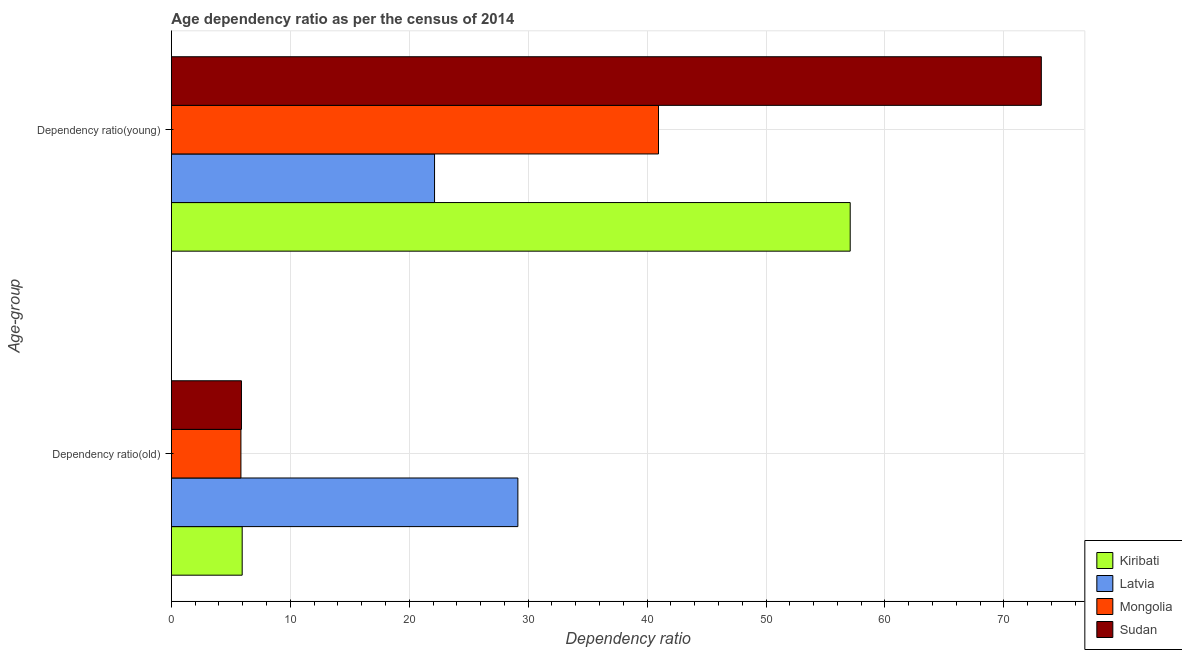How many bars are there on the 1st tick from the bottom?
Provide a short and direct response. 4. What is the label of the 1st group of bars from the top?
Provide a succinct answer. Dependency ratio(young). What is the age dependency ratio(old) in Latvia?
Offer a very short reply. 29.13. Across all countries, what is the maximum age dependency ratio(old)?
Offer a very short reply. 29.13. Across all countries, what is the minimum age dependency ratio(old)?
Offer a very short reply. 5.85. In which country was the age dependency ratio(old) maximum?
Give a very brief answer. Latvia. In which country was the age dependency ratio(young) minimum?
Provide a short and direct response. Latvia. What is the total age dependency ratio(old) in the graph?
Keep it short and to the point. 46.83. What is the difference between the age dependency ratio(young) in Mongolia and that in Kiribati?
Give a very brief answer. -16.12. What is the difference between the age dependency ratio(young) in Latvia and the age dependency ratio(old) in Sudan?
Provide a succinct answer. 16.24. What is the average age dependency ratio(old) per country?
Keep it short and to the point. 11.71. What is the difference between the age dependency ratio(young) and age dependency ratio(old) in Latvia?
Your response must be concise. -7.01. What is the ratio of the age dependency ratio(young) in Sudan to that in Mongolia?
Your answer should be compact. 1.79. What does the 1st bar from the top in Dependency ratio(old) represents?
Provide a short and direct response. Sudan. What does the 1st bar from the bottom in Dependency ratio(old) represents?
Ensure brevity in your answer.  Kiribati. How many bars are there?
Keep it short and to the point. 8. Are all the bars in the graph horizontal?
Offer a very short reply. Yes. How many countries are there in the graph?
Ensure brevity in your answer.  4. What is the difference between two consecutive major ticks on the X-axis?
Make the answer very short. 10. Are the values on the major ticks of X-axis written in scientific E-notation?
Provide a succinct answer. No. Does the graph contain any zero values?
Your answer should be very brief. No. Does the graph contain grids?
Ensure brevity in your answer.  Yes. How many legend labels are there?
Give a very brief answer. 4. How are the legend labels stacked?
Offer a very short reply. Vertical. What is the title of the graph?
Your answer should be very brief. Age dependency ratio as per the census of 2014. Does "Micronesia" appear as one of the legend labels in the graph?
Your response must be concise. No. What is the label or title of the X-axis?
Ensure brevity in your answer.  Dependency ratio. What is the label or title of the Y-axis?
Offer a terse response. Age-group. What is the Dependency ratio in Kiribati in Dependency ratio(old)?
Provide a succinct answer. 5.95. What is the Dependency ratio of Latvia in Dependency ratio(old)?
Your response must be concise. 29.13. What is the Dependency ratio of Mongolia in Dependency ratio(old)?
Offer a very short reply. 5.85. What is the Dependency ratio of Sudan in Dependency ratio(old)?
Your answer should be compact. 5.89. What is the Dependency ratio in Kiribati in Dependency ratio(young)?
Provide a short and direct response. 57.08. What is the Dependency ratio in Latvia in Dependency ratio(young)?
Provide a short and direct response. 22.13. What is the Dependency ratio in Mongolia in Dependency ratio(young)?
Offer a terse response. 40.96. What is the Dependency ratio of Sudan in Dependency ratio(young)?
Your answer should be very brief. 73.15. Across all Age-group, what is the maximum Dependency ratio of Kiribati?
Provide a succinct answer. 57.08. Across all Age-group, what is the maximum Dependency ratio in Latvia?
Your answer should be very brief. 29.13. Across all Age-group, what is the maximum Dependency ratio of Mongolia?
Offer a very short reply. 40.96. Across all Age-group, what is the maximum Dependency ratio of Sudan?
Keep it short and to the point. 73.15. Across all Age-group, what is the minimum Dependency ratio of Kiribati?
Keep it short and to the point. 5.95. Across all Age-group, what is the minimum Dependency ratio of Latvia?
Keep it short and to the point. 22.13. Across all Age-group, what is the minimum Dependency ratio in Mongolia?
Offer a terse response. 5.85. Across all Age-group, what is the minimum Dependency ratio of Sudan?
Make the answer very short. 5.89. What is the total Dependency ratio of Kiribati in the graph?
Your answer should be very brief. 63.03. What is the total Dependency ratio in Latvia in the graph?
Keep it short and to the point. 51.26. What is the total Dependency ratio of Mongolia in the graph?
Ensure brevity in your answer.  46.8. What is the total Dependency ratio of Sudan in the graph?
Offer a terse response. 79.04. What is the difference between the Dependency ratio in Kiribati in Dependency ratio(old) and that in Dependency ratio(young)?
Ensure brevity in your answer.  -51.12. What is the difference between the Dependency ratio in Latvia in Dependency ratio(old) and that in Dependency ratio(young)?
Your answer should be very brief. 7.01. What is the difference between the Dependency ratio in Mongolia in Dependency ratio(old) and that in Dependency ratio(young)?
Offer a terse response. -35.11. What is the difference between the Dependency ratio of Sudan in Dependency ratio(old) and that in Dependency ratio(young)?
Keep it short and to the point. -67.25. What is the difference between the Dependency ratio of Kiribati in Dependency ratio(old) and the Dependency ratio of Latvia in Dependency ratio(young)?
Give a very brief answer. -16.17. What is the difference between the Dependency ratio of Kiribati in Dependency ratio(old) and the Dependency ratio of Mongolia in Dependency ratio(young)?
Offer a very short reply. -35. What is the difference between the Dependency ratio of Kiribati in Dependency ratio(old) and the Dependency ratio of Sudan in Dependency ratio(young)?
Your response must be concise. -67.19. What is the difference between the Dependency ratio of Latvia in Dependency ratio(old) and the Dependency ratio of Mongolia in Dependency ratio(young)?
Provide a short and direct response. -11.82. What is the difference between the Dependency ratio of Latvia in Dependency ratio(old) and the Dependency ratio of Sudan in Dependency ratio(young)?
Provide a succinct answer. -44.01. What is the difference between the Dependency ratio of Mongolia in Dependency ratio(old) and the Dependency ratio of Sudan in Dependency ratio(young)?
Make the answer very short. -67.3. What is the average Dependency ratio in Kiribati per Age-group?
Ensure brevity in your answer.  31.51. What is the average Dependency ratio in Latvia per Age-group?
Give a very brief answer. 25.63. What is the average Dependency ratio in Mongolia per Age-group?
Offer a very short reply. 23.4. What is the average Dependency ratio of Sudan per Age-group?
Give a very brief answer. 39.52. What is the difference between the Dependency ratio in Kiribati and Dependency ratio in Latvia in Dependency ratio(old)?
Your answer should be compact. -23.18. What is the difference between the Dependency ratio of Kiribati and Dependency ratio of Mongolia in Dependency ratio(old)?
Offer a terse response. 0.11. What is the difference between the Dependency ratio in Kiribati and Dependency ratio in Sudan in Dependency ratio(old)?
Your response must be concise. 0.06. What is the difference between the Dependency ratio in Latvia and Dependency ratio in Mongolia in Dependency ratio(old)?
Your answer should be compact. 23.29. What is the difference between the Dependency ratio in Latvia and Dependency ratio in Sudan in Dependency ratio(old)?
Provide a succinct answer. 23.24. What is the difference between the Dependency ratio of Mongolia and Dependency ratio of Sudan in Dependency ratio(old)?
Ensure brevity in your answer.  -0.05. What is the difference between the Dependency ratio of Kiribati and Dependency ratio of Latvia in Dependency ratio(young)?
Give a very brief answer. 34.95. What is the difference between the Dependency ratio of Kiribati and Dependency ratio of Mongolia in Dependency ratio(young)?
Your answer should be compact. 16.12. What is the difference between the Dependency ratio in Kiribati and Dependency ratio in Sudan in Dependency ratio(young)?
Ensure brevity in your answer.  -16.07. What is the difference between the Dependency ratio of Latvia and Dependency ratio of Mongolia in Dependency ratio(young)?
Offer a very short reply. -18.83. What is the difference between the Dependency ratio in Latvia and Dependency ratio in Sudan in Dependency ratio(young)?
Your response must be concise. -51.02. What is the difference between the Dependency ratio in Mongolia and Dependency ratio in Sudan in Dependency ratio(young)?
Give a very brief answer. -32.19. What is the ratio of the Dependency ratio of Kiribati in Dependency ratio(old) to that in Dependency ratio(young)?
Ensure brevity in your answer.  0.1. What is the ratio of the Dependency ratio in Latvia in Dependency ratio(old) to that in Dependency ratio(young)?
Provide a short and direct response. 1.32. What is the ratio of the Dependency ratio of Mongolia in Dependency ratio(old) to that in Dependency ratio(young)?
Ensure brevity in your answer.  0.14. What is the ratio of the Dependency ratio of Sudan in Dependency ratio(old) to that in Dependency ratio(young)?
Offer a very short reply. 0.08. What is the difference between the highest and the second highest Dependency ratio in Kiribati?
Your answer should be very brief. 51.12. What is the difference between the highest and the second highest Dependency ratio of Latvia?
Provide a succinct answer. 7.01. What is the difference between the highest and the second highest Dependency ratio of Mongolia?
Your answer should be very brief. 35.11. What is the difference between the highest and the second highest Dependency ratio of Sudan?
Your answer should be compact. 67.25. What is the difference between the highest and the lowest Dependency ratio in Kiribati?
Your answer should be compact. 51.12. What is the difference between the highest and the lowest Dependency ratio of Latvia?
Your response must be concise. 7.01. What is the difference between the highest and the lowest Dependency ratio in Mongolia?
Provide a succinct answer. 35.11. What is the difference between the highest and the lowest Dependency ratio of Sudan?
Provide a succinct answer. 67.25. 